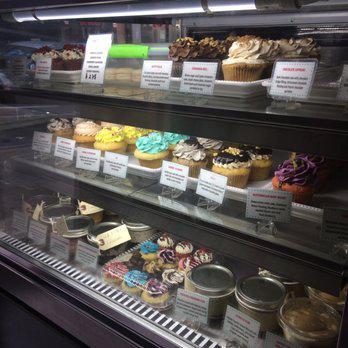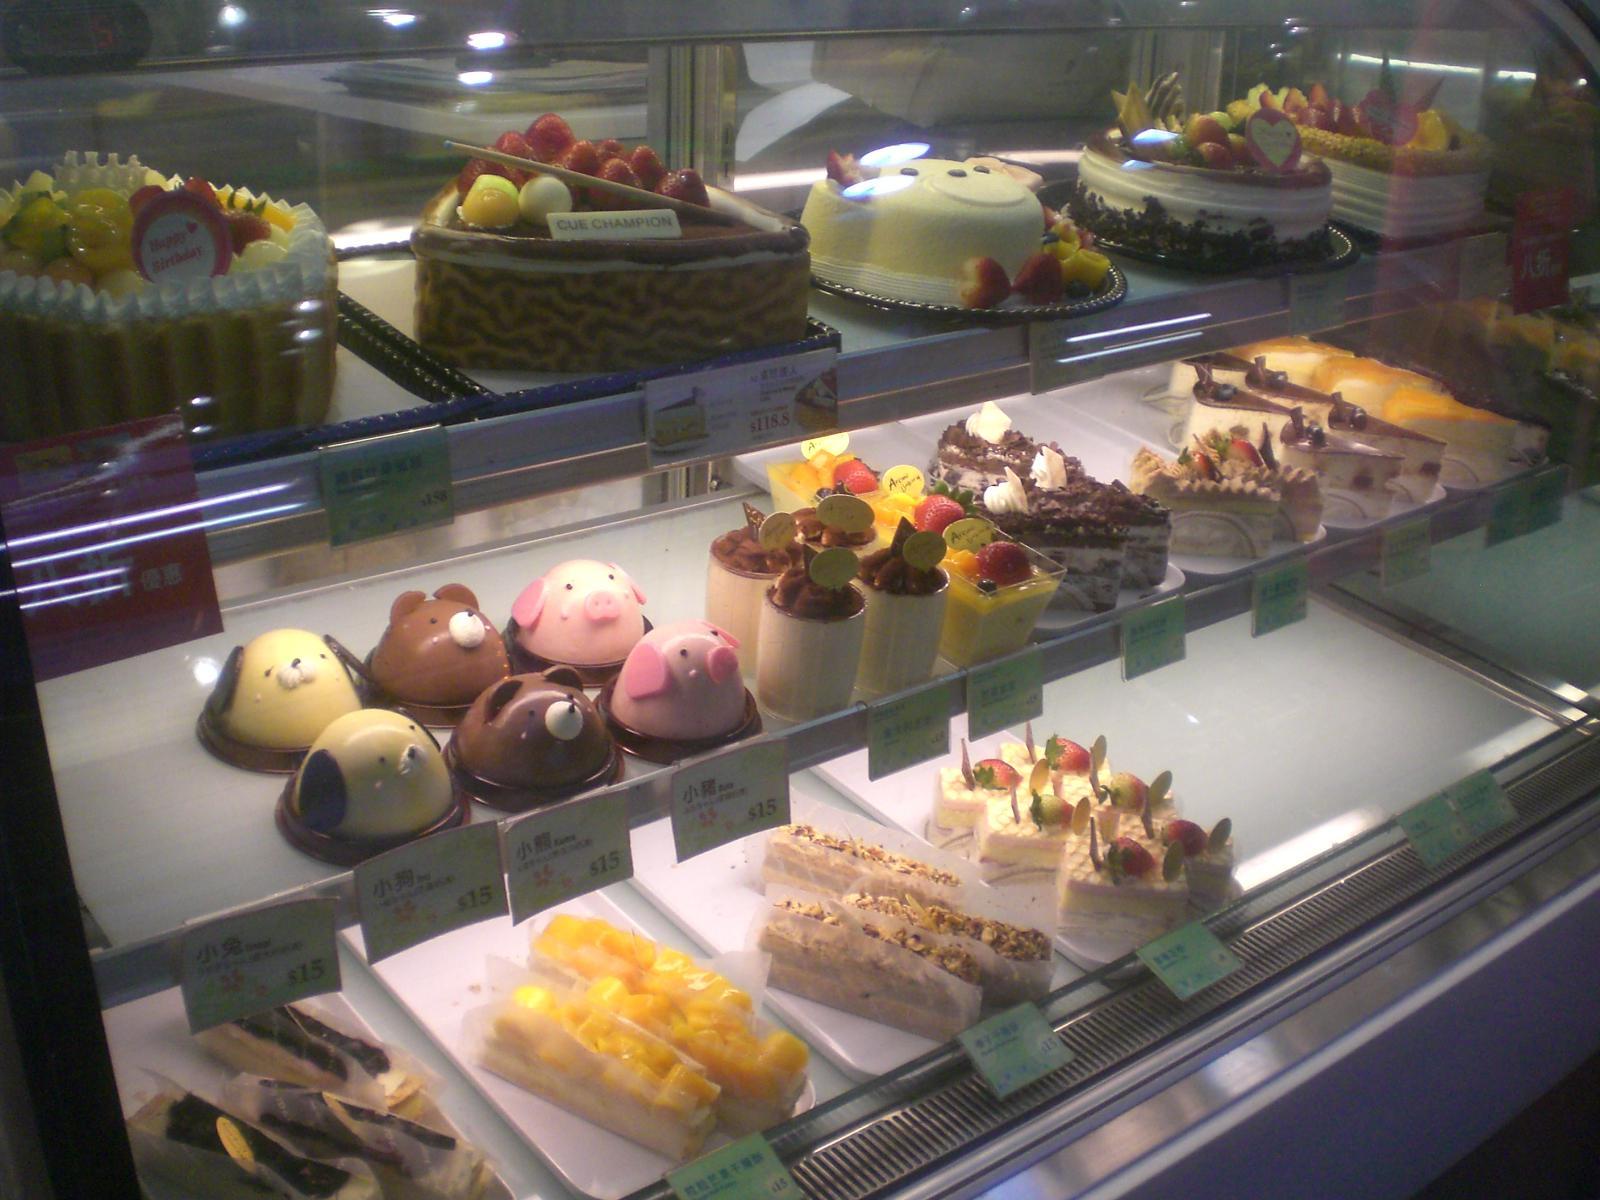The first image is the image on the left, the second image is the image on the right. Assess this claim about the two images: "There are at least 4 full size cakes in one of the images.". Correct or not? Answer yes or no. Yes. 